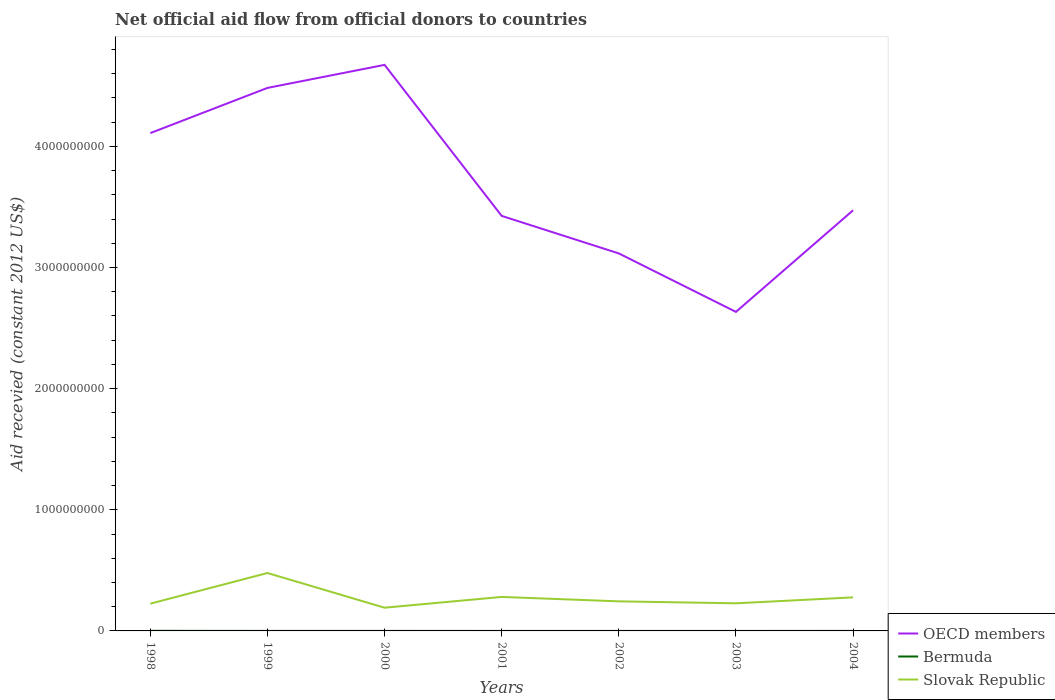How many different coloured lines are there?
Ensure brevity in your answer.  3. Is the number of lines equal to the number of legend labels?
Your response must be concise. Yes. Across all years, what is the maximum total aid received in Slovak Republic?
Keep it short and to the point. 1.92e+08. What is the total total aid received in OECD members in the graph?
Keep it short and to the point. -8.39e+08. What is the difference between the highest and the second highest total aid received in OECD members?
Your answer should be compact. 2.04e+09. How many years are there in the graph?
Your answer should be very brief. 7. Are the values on the major ticks of Y-axis written in scientific E-notation?
Your response must be concise. No. Does the graph contain any zero values?
Ensure brevity in your answer.  No. Where does the legend appear in the graph?
Ensure brevity in your answer.  Bottom right. How many legend labels are there?
Offer a very short reply. 3. What is the title of the graph?
Offer a terse response. Net official aid flow from official donors to countries. Does "North America" appear as one of the legend labels in the graph?
Make the answer very short. No. What is the label or title of the X-axis?
Ensure brevity in your answer.  Years. What is the label or title of the Y-axis?
Give a very brief answer. Aid recevied (constant 2012 US$). What is the Aid recevied (constant 2012 US$) of OECD members in 1998?
Offer a very short reply. 4.11e+09. What is the Aid recevied (constant 2012 US$) of Bermuda in 1998?
Give a very brief answer. 7.40e+05. What is the Aid recevied (constant 2012 US$) in Slovak Republic in 1998?
Give a very brief answer. 2.25e+08. What is the Aid recevied (constant 2012 US$) of OECD members in 1999?
Make the answer very short. 4.48e+09. What is the Aid recevied (constant 2012 US$) in Bermuda in 1999?
Your answer should be very brief. 1.30e+05. What is the Aid recevied (constant 2012 US$) in Slovak Republic in 1999?
Your answer should be compact. 4.78e+08. What is the Aid recevied (constant 2012 US$) of OECD members in 2000?
Provide a short and direct response. 4.67e+09. What is the Aid recevied (constant 2012 US$) of Bermuda in 2000?
Keep it short and to the point. 1.10e+05. What is the Aid recevied (constant 2012 US$) in Slovak Republic in 2000?
Your response must be concise. 1.92e+08. What is the Aid recevied (constant 2012 US$) in OECD members in 2001?
Offer a very short reply. 3.43e+09. What is the Aid recevied (constant 2012 US$) in Bermuda in 2001?
Ensure brevity in your answer.  4.00e+04. What is the Aid recevied (constant 2012 US$) in Slovak Republic in 2001?
Offer a terse response. 2.81e+08. What is the Aid recevied (constant 2012 US$) of OECD members in 2002?
Ensure brevity in your answer.  3.12e+09. What is the Aid recevied (constant 2012 US$) in Slovak Republic in 2002?
Your answer should be very brief. 2.44e+08. What is the Aid recevied (constant 2012 US$) in OECD members in 2003?
Offer a very short reply. 2.63e+09. What is the Aid recevied (constant 2012 US$) of Bermuda in 2003?
Provide a succinct answer. 4.00e+04. What is the Aid recevied (constant 2012 US$) in Slovak Republic in 2003?
Keep it short and to the point. 2.28e+08. What is the Aid recevied (constant 2012 US$) in OECD members in 2004?
Ensure brevity in your answer.  3.47e+09. What is the Aid recevied (constant 2012 US$) of Slovak Republic in 2004?
Ensure brevity in your answer.  2.77e+08. Across all years, what is the maximum Aid recevied (constant 2012 US$) of OECD members?
Your answer should be compact. 4.67e+09. Across all years, what is the maximum Aid recevied (constant 2012 US$) of Bermuda?
Offer a terse response. 7.40e+05. Across all years, what is the maximum Aid recevied (constant 2012 US$) in Slovak Republic?
Ensure brevity in your answer.  4.78e+08. Across all years, what is the minimum Aid recevied (constant 2012 US$) in OECD members?
Keep it short and to the point. 2.63e+09. Across all years, what is the minimum Aid recevied (constant 2012 US$) in Slovak Republic?
Keep it short and to the point. 1.92e+08. What is the total Aid recevied (constant 2012 US$) in OECD members in the graph?
Keep it short and to the point. 2.59e+1. What is the total Aid recevied (constant 2012 US$) in Bermuda in the graph?
Ensure brevity in your answer.  1.20e+06. What is the total Aid recevied (constant 2012 US$) of Slovak Republic in the graph?
Offer a terse response. 1.92e+09. What is the difference between the Aid recevied (constant 2012 US$) of OECD members in 1998 and that in 1999?
Make the answer very short. -3.73e+08. What is the difference between the Aid recevied (constant 2012 US$) of Bermuda in 1998 and that in 1999?
Provide a succinct answer. 6.10e+05. What is the difference between the Aid recevied (constant 2012 US$) of Slovak Republic in 1998 and that in 1999?
Provide a short and direct response. -2.53e+08. What is the difference between the Aid recevied (constant 2012 US$) in OECD members in 1998 and that in 2000?
Provide a succinct answer. -5.63e+08. What is the difference between the Aid recevied (constant 2012 US$) of Bermuda in 1998 and that in 2000?
Keep it short and to the point. 6.30e+05. What is the difference between the Aid recevied (constant 2012 US$) in Slovak Republic in 1998 and that in 2000?
Make the answer very short. 3.33e+07. What is the difference between the Aid recevied (constant 2012 US$) of OECD members in 1998 and that in 2001?
Your answer should be very brief. 6.84e+08. What is the difference between the Aid recevied (constant 2012 US$) in Bermuda in 1998 and that in 2001?
Provide a short and direct response. 7.00e+05. What is the difference between the Aid recevied (constant 2012 US$) of Slovak Republic in 1998 and that in 2001?
Provide a short and direct response. -5.56e+07. What is the difference between the Aid recevied (constant 2012 US$) of OECD members in 1998 and that in 2002?
Offer a terse response. 9.93e+08. What is the difference between the Aid recevied (constant 2012 US$) of Bermuda in 1998 and that in 2002?
Your response must be concise. 7.10e+05. What is the difference between the Aid recevied (constant 2012 US$) in Slovak Republic in 1998 and that in 2002?
Provide a short and direct response. -1.91e+07. What is the difference between the Aid recevied (constant 2012 US$) of OECD members in 1998 and that in 2003?
Provide a short and direct response. 1.48e+09. What is the difference between the Aid recevied (constant 2012 US$) in Slovak Republic in 1998 and that in 2003?
Offer a terse response. -2.98e+06. What is the difference between the Aid recevied (constant 2012 US$) of OECD members in 1998 and that in 2004?
Your answer should be very brief. 6.38e+08. What is the difference between the Aid recevied (constant 2012 US$) of Bermuda in 1998 and that in 2004?
Your answer should be compact. 6.30e+05. What is the difference between the Aid recevied (constant 2012 US$) of Slovak Republic in 1998 and that in 2004?
Your answer should be very brief. -5.20e+07. What is the difference between the Aid recevied (constant 2012 US$) in OECD members in 1999 and that in 2000?
Provide a succinct answer. -1.90e+08. What is the difference between the Aid recevied (constant 2012 US$) in Bermuda in 1999 and that in 2000?
Provide a short and direct response. 2.00e+04. What is the difference between the Aid recevied (constant 2012 US$) of Slovak Republic in 1999 and that in 2000?
Your answer should be compact. 2.86e+08. What is the difference between the Aid recevied (constant 2012 US$) in OECD members in 1999 and that in 2001?
Give a very brief answer. 1.06e+09. What is the difference between the Aid recevied (constant 2012 US$) of Bermuda in 1999 and that in 2001?
Make the answer very short. 9.00e+04. What is the difference between the Aid recevied (constant 2012 US$) of Slovak Republic in 1999 and that in 2001?
Offer a very short reply. 1.98e+08. What is the difference between the Aid recevied (constant 2012 US$) in OECD members in 1999 and that in 2002?
Provide a short and direct response. 1.37e+09. What is the difference between the Aid recevied (constant 2012 US$) in Bermuda in 1999 and that in 2002?
Ensure brevity in your answer.  1.00e+05. What is the difference between the Aid recevied (constant 2012 US$) of Slovak Republic in 1999 and that in 2002?
Your response must be concise. 2.34e+08. What is the difference between the Aid recevied (constant 2012 US$) of OECD members in 1999 and that in 2003?
Your answer should be very brief. 1.85e+09. What is the difference between the Aid recevied (constant 2012 US$) in Bermuda in 1999 and that in 2003?
Your answer should be very brief. 9.00e+04. What is the difference between the Aid recevied (constant 2012 US$) in Slovak Republic in 1999 and that in 2003?
Your answer should be compact. 2.50e+08. What is the difference between the Aid recevied (constant 2012 US$) of OECD members in 1999 and that in 2004?
Give a very brief answer. 1.01e+09. What is the difference between the Aid recevied (constant 2012 US$) of Slovak Republic in 1999 and that in 2004?
Your answer should be very brief. 2.01e+08. What is the difference between the Aid recevied (constant 2012 US$) in OECD members in 2000 and that in 2001?
Your answer should be compact. 1.25e+09. What is the difference between the Aid recevied (constant 2012 US$) of Bermuda in 2000 and that in 2001?
Provide a succinct answer. 7.00e+04. What is the difference between the Aid recevied (constant 2012 US$) of Slovak Republic in 2000 and that in 2001?
Keep it short and to the point. -8.90e+07. What is the difference between the Aid recevied (constant 2012 US$) in OECD members in 2000 and that in 2002?
Your answer should be very brief. 1.56e+09. What is the difference between the Aid recevied (constant 2012 US$) of Slovak Republic in 2000 and that in 2002?
Offer a terse response. -5.24e+07. What is the difference between the Aid recevied (constant 2012 US$) of OECD members in 2000 and that in 2003?
Make the answer very short. 2.04e+09. What is the difference between the Aid recevied (constant 2012 US$) of Bermuda in 2000 and that in 2003?
Keep it short and to the point. 7.00e+04. What is the difference between the Aid recevied (constant 2012 US$) of Slovak Republic in 2000 and that in 2003?
Offer a very short reply. -3.63e+07. What is the difference between the Aid recevied (constant 2012 US$) of OECD members in 2000 and that in 2004?
Provide a short and direct response. 1.20e+09. What is the difference between the Aid recevied (constant 2012 US$) of Bermuda in 2000 and that in 2004?
Your response must be concise. 0. What is the difference between the Aid recevied (constant 2012 US$) of Slovak Republic in 2000 and that in 2004?
Your answer should be compact. -8.53e+07. What is the difference between the Aid recevied (constant 2012 US$) in OECD members in 2001 and that in 2002?
Offer a terse response. 3.10e+08. What is the difference between the Aid recevied (constant 2012 US$) of Slovak Republic in 2001 and that in 2002?
Make the answer very short. 3.66e+07. What is the difference between the Aid recevied (constant 2012 US$) of OECD members in 2001 and that in 2003?
Provide a succinct answer. 7.93e+08. What is the difference between the Aid recevied (constant 2012 US$) in Bermuda in 2001 and that in 2003?
Provide a succinct answer. 0. What is the difference between the Aid recevied (constant 2012 US$) in Slovak Republic in 2001 and that in 2003?
Ensure brevity in your answer.  5.27e+07. What is the difference between the Aid recevied (constant 2012 US$) of OECD members in 2001 and that in 2004?
Your response must be concise. -4.60e+07. What is the difference between the Aid recevied (constant 2012 US$) in Slovak Republic in 2001 and that in 2004?
Provide a short and direct response. 3.66e+06. What is the difference between the Aid recevied (constant 2012 US$) of OECD members in 2002 and that in 2003?
Make the answer very short. 4.83e+08. What is the difference between the Aid recevied (constant 2012 US$) of Bermuda in 2002 and that in 2003?
Your answer should be compact. -10000. What is the difference between the Aid recevied (constant 2012 US$) of Slovak Republic in 2002 and that in 2003?
Ensure brevity in your answer.  1.61e+07. What is the difference between the Aid recevied (constant 2012 US$) of OECD members in 2002 and that in 2004?
Ensure brevity in your answer.  -3.56e+08. What is the difference between the Aid recevied (constant 2012 US$) in Bermuda in 2002 and that in 2004?
Keep it short and to the point. -8.00e+04. What is the difference between the Aid recevied (constant 2012 US$) of Slovak Republic in 2002 and that in 2004?
Offer a terse response. -3.29e+07. What is the difference between the Aid recevied (constant 2012 US$) in OECD members in 2003 and that in 2004?
Offer a terse response. -8.39e+08. What is the difference between the Aid recevied (constant 2012 US$) in Slovak Republic in 2003 and that in 2004?
Your response must be concise. -4.90e+07. What is the difference between the Aid recevied (constant 2012 US$) of OECD members in 1998 and the Aid recevied (constant 2012 US$) of Bermuda in 1999?
Make the answer very short. 4.11e+09. What is the difference between the Aid recevied (constant 2012 US$) of OECD members in 1998 and the Aid recevied (constant 2012 US$) of Slovak Republic in 1999?
Provide a succinct answer. 3.63e+09. What is the difference between the Aid recevied (constant 2012 US$) of Bermuda in 1998 and the Aid recevied (constant 2012 US$) of Slovak Republic in 1999?
Provide a succinct answer. -4.77e+08. What is the difference between the Aid recevied (constant 2012 US$) of OECD members in 1998 and the Aid recevied (constant 2012 US$) of Bermuda in 2000?
Your response must be concise. 4.11e+09. What is the difference between the Aid recevied (constant 2012 US$) in OECD members in 1998 and the Aid recevied (constant 2012 US$) in Slovak Republic in 2000?
Your answer should be very brief. 3.92e+09. What is the difference between the Aid recevied (constant 2012 US$) in Bermuda in 1998 and the Aid recevied (constant 2012 US$) in Slovak Republic in 2000?
Give a very brief answer. -1.91e+08. What is the difference between the Aid recevied (constant 2012 US$) of OECD members in 1998 and the Aid recevied (constant 2012 US$) of Bermuda in 2001?
Make the answer very short. 4.11e+09. What is the difference between the Aid recevied (constant 2012 US$) in OECD members in 1998 and the Aid recevied (constant 2012 US$) in Slovak Republic in 2001?
Provide a short and direct response. 3.83e+09. What is the difference between the Aid recevied (constant 2012 US$) in Bermuda in 1998 and the Aid recevied (constant 2012 US$) in Slovak Republic in 2001?
Your answer should be very brief. -2.80e+08. What is the difference between the Aid recevied (constant 2012 US$) in OECD members in 1998 and the Aid recevied (constant 2012 US$) in Bermuda in 2002?
Your answer should be compact. 4.11e+09. What is the difference between the Aid recevied (constant 2012 US$) in OECD members in 1998 and the Aid recevied (constant 2012 US$) in Slovak Republic in 2002?
Your response must be concise. 3.87e+09. What is the difference between the Aid recevied (constant 2012 US$) in Bermuda in 1998 and the Aid recevied (constant 2012 US$) in Slovak Republic in 2002?
Your answer should be compact. -2.43e+08. What is the difference between the Aid recevied (constant 2012 US$) in OECD members in 1998 and the Aid recevied (constant 2012 US$) in Bermuda in 2003?
Your response must be concise. 4.11e+09. What is the difference between the Aid recevied (constant 2012 US$) in OECD members in 1998 and the Aid recevied (constant 2012 US$) in Slovak Republic in 2003?
Your response must be concise. 3.88e+09. What is the difference between the Aid recevied (constant 2012 US$) in Bermuda in 1998 and the Aid recevied (constant 2012 US$) in Slovak Republic in 2003?
Offer a very short reply. -2.27e+08. What is the difference between the Aid recevied (constant 2012 US$) in OECD members in 1998 and the Aid recevied (constant 2012 US$) in Bermuda in 2004?
Your answer should be compact. 4.11e+09. What is the difference between the Aid recevied (constant 2012 US$) in OECD members in 1998 and the Aid recevied (constant 2012 US$) in Slovak Republic in 2004?
Ensure brevity in your answer.  3.83e+09. What is the difference between the Aid recevied (constant 2012 US$) of Bermuda in 1998 and the Aid recevied (constant 2012 US$) of Slovak Republic in 2004?
Your answer should be compact. -2.76e+08. What is the difference between the Aid recevied (constant 2012 US$) of OECD members in 1999 and the Aid recevied (constant 2012 US$) of Bermuda in 2000?
Your answer should be very brief. 4.48e+09. What is the difference between the Aid recevied (constant 2012 US$) of OECD members in 1999 and the Aid recevied (constant 2012 US$) of Slovak Republic in 2000?
Provide a succinct answer. 4.29e+09. What is the difference between the Aid recevied (constant 2012 US$) of Bermuda in 1999 and the Aid recevied (constant 2012 US$) of Slovak Republic in 2000?
Keep it short and to the point. -1.92e+08. What is the difference between the Aid recevied (constant 2012 US$) of OECD members in 1999 and the Aid recevied (constant 2012 US$) of Bermuda in 2001?
Offer a terse response. 4.48e+09. What is the difference between the Aid recevied (constant 2012 US$) in OECD members in 1999 and the Aid recevied (constant 2012 US$) in Slovak Republic in 2001?
Your answer should be very brief. 4.20e+09. What is the difference between the Aid recevied (constant 2012 US$) of Bermuda in 1999 and the Aid recevied (constant 2012 US$) of Slovak Republic in 2001?
Make the answer very short. -2.81e+08. What is the difference between the Aid recevied (constant 2012 US$) in OECD members in 1999 and the Aid recevied (constant 2012 US$) in Bermuda in 2002?
Your answer should be very brief. 4.48e+09. What is the difference between the Aid recevied (constant 2012 US$) of OECD members in 1999 and the Aid recevied (constant 2012 US$) of Slovak Republic in 2002?
Offer a very short reply. 4.24e+09. What is the difference between the Aid recevied (constant 2012 US$) in Bermuda in 1999 and the Aid recevied (constant 2012 US$) in Slovak Republic in 2002?
Provide a short and direct response. -2.44e+08. What is the difference between the Aid recevied (constant 2012 US$) of OECD members in 1999 and the Aid recevied (constant 2012 US$) of Bermuda in 2003?
Give a very brief answer. 4.48e+09. What is the difference between the Aid recevied (constant 2012 US$) in OECD members in 1999 and the Aid recevied (constant 2012 US$) in Slovak Republic in 2003?
Make the answer very short. 4.25e+09. What is the difference between the Aid recevied (constant 2012 US$) of Bermuda in 1999 and the Aid recevied (constant 2012 US$) of Slovak Republic in 2003?
Provide a succinct answer. -2.28e+08. What is the difference between the Aid recevied (constant 2012 US$) in OECD members in 1999 and the Aid recevied (constant 2012 US$) in Bermuda in 2004?
Give a very brief answer. 4.48e+09. What is the difference between the Aid recevied (constant 2012 US$) of OECD members in 1999 and the Aid recevied (constant 2012 US$) of Slovak Republic in 2004?
Offer a terse response. 4.21e+09. What is the difference between the Aid recevied (constant 2012 US$) in Bermuda in 1999 and the Aid recevied (constant 2012 US$) in Slovak Republic in 2004?
Provide a short and direct response. -2.77e+08. What is the difference between the Aid recevied (constant 2012 US$) in OECD members in 2000 and the Aid recevied (constant 2012 US$) in Bermuda in 2001?
Your answer should be very brief. 4.67e+09. What is the difference between the Aid recevied (constant 2012 US$) in OECD members in 2000 and the Aid recevied (constant 2012 US$) in Slovak Republic in 2001?
Offer a terse response. 4.39e+09. What is the difference between the Aid recevied (constant 2012 US$) of Bermuda in 2000 and the Aid recevied (constant 2012 US$) of Slovak Republic in 2001?
Ensure brevity in your answer.  -2.81e+08. What is the difference between the Aid recevied (constant 2012 US$) of OECD members in 2000 and the Aid recevied (constant 2012 US$) of Bermuda in 2002?
Your response must be concise. 4.67e+09. What is the difference between the Aid recevied (constant 2012 US$) of OECD members in 2000 and the Aid recevied (constant 2012 US$) of Slovak Republic in 2002?
Offer a terse response. 4.43e+09. What is the difference between the Aid recevied (constant 2012 US$) of Bermuda in 2000 and the Aid recevied (constant 2012 US$) of Slovak Republic in 2002?
Offer a terse response. -2.44e+08. What is the difference between the Aid recevied (constant 2012 US$) of OECD members in 2000 and the Aid recevied (constant 2012 US$) of Bermuda in 2003?
Offer a terse response. 4.67e+09. What is the difference between the Aid recevied (constant 2012 US$) in OECD members in 2000 and the Aid recevied (constant 2012 US$) in Slovak Republic in 2003?
Make the answer very short. 4.44e+09. What is the difference between the Aid recevied (constant 2012 US$) of Bermuda in 2000 and the Aid recevied (constant 2012 US$) of Slovak Republic in 2003?
Your answer should be very brief. -2.28e+08. What is the difference between the Aid recevied (constant 2012 US$) of OECD members in 2000 and the Aid recevied (constant 2012 US$) of Bermuda in 2004?
Provide a succinct answer. 4.67e+09. What is the difference between the Aid recevied (constant 2012 US$) in OECD members in 2000 and the Aid recevied (constant 2012 US$) in Slovak Republic in 2004?
Provide a short and direct response. 4.40e+09. What is the difference between the Aid recevied (constant 2012 US$) of Bermuda in 2000 and the Aid recevied (constant 2012 US$) of Slovak Republic in 2004?
Offer a terse response. -2.77e+08. What is the difference between the Aid recevied (constant 2012 US$) in OECD members in 2001 and the Aid recevied (constant 2012 US$) in Bermuda in 2002?
Your answer should be compact. 3.43e+09. What is the difference between the Aid recevied (constant 2012 US$) of OECD members in 2001 and the Aid recevied (constant 2012 US$) of Slovak Republic in 2002?
Provide a succinct answer. 3.18e+09. What is the difference between the Aid recevied (constant 2012 US$) of Bermuda in 2001 and the Aid recevied (constant 2012 US$) of Slovak Republic in 2002?
Offer a very short reply. -2.44e+08. What is the difference between the Aid recevied (constant 2012 US$) of OECD members in 2001 and the Aid recevied (constant 2012 US$) of Bermuda in 2003?
Provide a succinct answer. 3.43e+09. What is the difference between the Aid recevied (constant 2012 US$) in OECD members in 2001 and the Aid recevied (constant 2012 US$) in Slovak Republic in 2003?
Your response must be concise. 3.20e+09. What is the difference between the Aid recevied (constant 2012 US$) of Bermuda in 2001 and the Aid recevied (constant 2012 US$) of Slovak Republic in 2003?
Make the answer very short. -2.28e+08. What is the difference between the Aid recevied (constant 2012 US$) in OECD members in 2001 and the Aid recevied (constant 2012 US$) in Bermuda in 2004?
Your answer should be very brief. 3.43e+09. What is the difference between the Aid recevied (constant 2012 US$) of OECD members in 2001 and the Aid recevied (constant 2012 US$) of Slovak Republic in 2004?
Provide a succinct answer. 3.15e+09. What is the difference between the Aid recevied (constant 2012 US$) in Bermuda in 2001 and the Aid recevied (constant 2012 US$) in Slovak Republic in 2004?
Keep it short and to the point. -2.77e+08. What is the difference between the Aid recevied (constant 2012 US$) in OECD members in 2002 and the Aid recevied (constant 2012 US$) in Bermuda in 2003?
Your answer should be compact. 3.12e+09. What is the difference between the Aid recevied (constant 2012 US$) in OECD members in 2002 and the Aid recevied (constant 2012 US$) in Slovak Republic in 2003?
Offer a very short reply. 2.89e+09. What is the difference between the Aid recevied (constant 2012 US$) in Bermuda in 2002 and the Aid recevied (constant 2012 US$) in Slovak Republic in 2003?
Offer a very short reply. -2.28e+08. What is the difference between the Aid recevied (constant 2012 US$) in OECD members in 2002 and the Aid recevied (constant 2012 US$) in Bermuda in 2004?
Offer a terse response. 3.12e+09. What is the difference between the Aid recevied (constant 2012 US$) in OECD members in 2002 and the Aid recevied (constant 2012 US$) in Slovak Republic in 2004?
Keep it short and to the point. 2.84e+09. What is the difference between the Aid recevied (constant 2012 US$) in Bermuda in 2002 and the Aid recevied (constant 2012 US$) in Slovak Republic in 2004?
Your answer should be compact. -2.77e+08. What is the difference between the Aid recevied (constant 2012 US$) of OECD members in 2003 and the Aid recevied (constant 2012 US$) of Bermuda in 2004?
Provide a short and direct response. 2.63e+09. What is the difference between the Aid recevied (constant 2012 US$) in OECD members in 2003 and the Aid recevied (constant 2012 US$) in Slovak Republic in 2004?
Your answer should be very brief. 2.36e+09. What is the difference between the Aid recevied (constant 2012 US$) in Bermuda in 2003 and the Aid recevied (constant 2012 US$) in Slovak Republic in 2004?
Make the answer very short. -2.77e+08. What is the average Aid recevied (constant 2012 US$) of OECD members per year?
Ensure brevity in your answer.  3.70e+09. What is the average Aid recevied (constant 2012 US$) in Bermuda per year?
Give a very brief answer. 1.71e+05. What is the average Aid recevied (constant 2012 US$) of Slovak Republic per year?
Offer a very short reply. 2.75e+08. In the year 1998, what is the difference between the Aid recevied (constant 2012 US$) of OECD members and Aid recevied (constant 2012 US$) of Bermuda?
Keep it short and to the point. 4.11e+09. In the year 1998, what is the difference between the Aid recevied (constant 2012 US$) of OECD members and Aid recevied (constant 2012 US$) of Slovak Republic?
Your answer should be very brief. 3.88e+09. In the year 1998, what is the difference between the Aid recevied (constant 2012 US$) in Bermuda and Aid recevied (constant 2012 US$) in Slovak Republic?
Your answer should be compact. -2.24e+08. In the year 1999, what is the difference between the Aid recevied (constant 2012 US$) of OECD members and Aid recevied (constant 2012 US$) of Bermuda?
Keep it short and to the point. 4.48e+09. In the year 1999, what is the difference between the Aid recevied (constant 2012 US$) in OECD members and Aid recevied (constant 2012 US$) in Slovak Republic?
Offer a very short reply. 4.00e+09. In the year 1999, what is the difference between the Aid recevied (constant 2012 US$) of Bermuda and Aid recevied (constant 2012 US$) of Slovak Republic?
Provide a short and direct response. -4.78e+08. In the year 2000, what is the difference between the Aid recevied (constant 2012 US$) in OECD members and Aid recevied (constant 2012 US$) in Bermuda?
Give a very brief answer. 4.67e+09. In the year 2000, what is the difference between the Aid recevied (constant 2012 US$) in OECD members and Aid recevied (constant 2012 US$) in Slovak Republic?
Your answer should be very brief. 4.48e+09. In the year 2000, what is the difference between the Aid recevied (constant 2012 US$) in Bermuda and Aid recevied (constant 2012 US$) in Slovak Republic?
Offer a very short reply. -1.92e+08. In the year 2001, what is the difference between the Aid recevied (constant 2012 US$) in OECD members and Aid recevied (constant 2012 US$) in Bermuda?
Your response must be concise. 3.43e+09. In the year 2001, what is the difference between the Aid recevied (constant 2012 US$) in OECD members and Aid recevied (constant 2012 US$) in Slovak Republic?
Make the answer very short. 3.15e+09. In the year 2001, what is the difference between the Aid recevied (constant 2012 US$) in Bermuda and Aid recevied (constant 2012 US$) in Slovak Republic?
Provide a short and direct response. -2.81e+08. In the year 2002, what is the difference between the Aid recevied (constant 2012 US$) of OECD members and Aid recevied (constant 2012 US$) of Bermuda?
Your answer should be very brief. 3.12e+09. In the year 2002, what is the difference between the Aid recevied (constant 2012 US$) of OECD members and Aid recevied (constant 2012 US$) of Slovak Republic?
Provide a succinct answer. 2.87e+09. In the year 2002, what is the difference between the Aid recevied (constant 2012 US$) of Bermuda and Aid recevied (constant 2012 US$) of Slovak Republic?
Your response must be concise. -2.44e+08. In the year 2003, what is the difference between the Aid recevied (constant 2012 US$) of OECD members and Aid recevied (constant 2012 US$) of Bermuda?
Provide a short and direct response. 2.63e+09. In the year 2003, what is the difference between the Aid recevied (constant 2012 US$) in OECD members and Aid recevied (constant 2012 US$) in Slovak Republic?
Offer a terse response. 2.41e+09. In the year 2003, what is the difference between the Aid recevied (constant 2012 US$) of Bermuda and Aid recevied (constant 2012 US$) of Slovak Republic?
Provide a short and direct response. -2.28e+08. In the year 2004, what is the difference between the Aid recevied (constant 2012 US$) in OECD members and Aid recevied (constant 2012 US$) in Bermuda?
Your answer should be very brief. 3.47e+09. In the year 2004, what is the difference between the Aid recevied (constant 2012 US$) of OECD members and Aid recevied (constant 2012 US$) of Slovak Republic?
Give a very brief answer. 3.20e+09. In the year 2004, what is the difference between the Aid recevied (constant 2012 US$) of Bermuda and Aid recevied (constant 2012 US$) of Slovak Republic?
Your answer should be very brief. -2.77e+08. What is the ratio of the Aid recevied (constant 2012 US$) of OECD members in 1998 to that in 1999?
Your answer should be compact. 0.92. What is the ratio of the Aid recevied (constant 2012 US$) in Bermuda in 1998 to that in 1999?
Offer a very short reply. 5.69. What is the ratio of the Aid recevied (constant 2012 US$) in Slovak Republic in 1998 to that in 1999?
Provide a succinct answer. 0.47. What is the ratio of the Aid recevied (constant 2012 US$) of OECD members in 1998 to that in 2000?
Offer a very short reply. 0.88. What is the ratio of the Aid recevied (constant 2012 US$) in Bermuda in 1998 to that in 2000?
Your response must be concise. 6.73. What is the ratio of the Aid recevied (constant 2012 US$) in Slovak Republic in 1998 to that in 2000?
Your response must be concise. 1.17. What is the ratio of the Aid recevied (constant 2012 US$) in OECD members in 1998 to that in 2001?
Your answer should be compact. 1.2. What is the ratio of the Aid recevied (constant 2012 US$) in Bermuda in 1998 to that in 2001?
Give a very brief answer. 18.5. What is the ratio of the Aid recevied (constant 2012 US$) of Slovak Republic in 1998 to that in 2001?
Your answer should be compact. 0.8. What is the ratio of the Aid recevied (constant 2012 US$) in OECD members in 1998 to that in 2002?
Offer a very short reply. 1.32. What is the ratio of the Aid recevied (constant 2012 US$) of Bermuda in 1998 to that in 2002?
Your answer should be compact. 24.67. What is the ratio of the Aid recevied (constant 2012 US$) in Slovak Republic in 1998 to that in 2002?
Your response must be concise. 0.92. What is the ratio of the Aid recevied (constant 2012 US$) of OECD members in 1998 to that in 2003?
Make the answer very short. 1.56. What is the ratio of the Aid recevied (constant 2012 US$) in Slovak Republic in 1998 to that in 2003?
Make the answer very short. 0.99. What is the ratio of the Aid recevied (constant 2012 US$) of OECD members in 1998 to that in 2004?
Keep it short and to the point. 1.18. What is the ratio of the Aid recevied (constant 2012 US$) of Bermuda in 1998 to that in 2004?
Offer a very short reply. 6.73. What is the ratio of the Aid recevied (constant 2012 US$) of Slovak Republic in 1998 to that in 2004?
Your response must be concise. 0.81. What is the ratio of the Aid recevied (constant 2012 US$) in OECD members in 1999 to that in 2000?
Your response must be concise. 0.96. What is the ratio of the Aid recevied (constant 2012 US$) in Bermuda in 1999 to that in 2000?
Provide a short and direct response. 1.18. What is the ratio of the Aid recevied (constant 2012 US$) of Slovak Republic in 1999 to that in 2000?
Your answer should be compact. 2.49. What is the ratio of the Aid recevied (constant 2012 US$) of OECD members in 1999 to that in 2001?
Offer a very short reply. 1.31. What is the ratio of the Aid recevied (constant 2012 US$) in Slovak Republic in 1999 to that in 2001?
Keep it short and to the point. 1.7. What is the ratio of the Aid recevied (constant 2012 US$) in OECD members in 1999 to that in 2002?
Your response must be concise. 1.44. What is the ratio of the Aid recevied (constant 2012 US$) in Bermuda in 1999 to that in 2002?
Your answer should be compact. 4.33. What is the ratio of the Aid recevied (constant 2012 US$) in Slovak Republic in 1999 to that in 2002?
Offer a terse response. 1.96. What is the ratio of the Aid recevied (constant 2012 US$) in OECD members in 1999 to that in 2003?
Offer a very short reply. 1.7. What is the ratio of the Aid recevied (constant 2012 US$) of Slovak Republic in 1999 to that in 2003?
Keep it short and to the point. 2.1. What is the ratio of the Aid recevied (constant 2012 US$) of OECD members in 1999 to that in 2004?
Offer a terse response. 1.29. What is the ratio of the Aid recevied (constant 2012 US$) in Bermuda in 1999 to that in 2004?
Make the answer very short. 1.18. What is the ratio of the Aid recevied (constant 2012 US$) of Slovak Republic in 1999 to that in 2004?
Keep it short and to the point. 1.73. What is the ratio of the Aid recevied (constant 2012 US$) of OECD members in 2000 to that in 2001?
Ensure brevity in your answer.  1.36. What is the ratio of the Aid recevied (constant 2012 US$) of Bermuda in 2000 to that in 2001?
Your answer should be compact. 2.75. What is the ratio of the Aid recevied (constant 2012 US$) in Slovak Republic in 2000 to that in 2001?
Offer a terse response. 0.68. What is the ratio of the Aid recevied (constant 2012 US$) in OECD members in 2000 to that in 2002?
Offer a very short reply. 1.5. What is the ratio of the Aid recevied (constant 2012 US$) of Bermuda in 2000 to that in 2002?
Give a very brief answer. 3.67. What is the ratio of the Aid recevied (constant 2012 US$) of Slovak Republic in 2000 to that in 2002?
Offer a terse response. 0.79. What is the ratio of the Aid recevied (constant 2012 US$) of OECD members in 2000 to that in 2003?
Make the answer very short. 1.77. What is the ratio of the Aid recevied (constant 2012 US$) of Bermuda in 2000 to that in 2003?
Make the answer very short. 2.75. What is the ratio of the Aid recevied (constant 2012 US$) of Slovak Republic in 2000 to that in 2003?
Your answer should be compact. 0.84. What is the ratio of the Aid recevied (constant 2012 US$) in OECD members in 2000 to that in 2004?
Offer a very short reply. 1.35. What is the ratio of the Aid recevied (constant 2012 US$) of Slovak Republic in 2000 to that in 2004?
Your answer should be compact. 0.69. What is the ratio of the Aid recevied (constant 2012 US$) of OECD members in 2001 to that in 2002?
Your answer should be very brief. 1.1. What is the ratio of the Aid recevied (constant 2012 US$) of Slovak Republic in 2001 to that in 2002?
Your answer should be compact. 1.15. What is the ratio of the Aid recevied (constant 2012 US$) in OECD members in 2001 to that in 2003?
Offer a very short reply. 1.3. What is the ratio of the Aid recevied (constant 2012 US$) of Bermuda in 2001 to that in 2003?
Provide a short and direct response. 1. What is the ratio of the Aid recevied (constant 2012 US$) in Slovak Republic in 2001 to that in 2003?
Provide a short and direct response. 1.23. What is the ratio of the Aid recevied (constant 2012 US$) in OECD members in 2001 to that in 2004?
Provide a succinct answer. 0.99. What is the ratio of the Aid recevied (constant 2012 US$) of Bermuda in 2001 to that in 2004?
Offer a very short reply. 0.36. What is the ratio of the Aid recevied (constant 2012 US$) in Slovak Republic in 2001 to that in 2004?
Your answer should be very brief. 1.01. What is the ratio of the Aid recevied (constant 2012 US$) in OECD members in 2002 to that in 2003?
Offer a terse response. 1.18. What is the ratio of the Aid recevied (constant 2012 US$) of Bermuda in 2002 to that in 2003?
Your answer should be very brief. 0.75. What is the ratio of the Aid recevied (constant 2012 US$) in Slovak Republic in 2002 to that in 2003?
Make the answer very short. 1.07. What is the ratio of the Aid recevied (constant 2012 US$) of OECD members in 2002 to that in 2004?
Offer a terse response. 0.9. What is the ratio of the Aid recevied (constant 2012 US$) of Bermuda in 2002 to that in 2004?
Your response must be concise. 0.27. What is the ratio of the Aid recevied (constant 2012 US$) in Slovak Republic in 2002 to that in 2004?
Your response must be concise. 0.88. What is the ratio of the Aid recevied (constant 2012 US$) of OECD members in 2003 to that in 2004?
Your answer should be very brief. 0.76. What is the ratio of the Aid recevied (constant 2012 US$) in Bermuda in 2003 to that in 2004?
Offer a terse response. 0.36. What is the ratio of the Aid recevied (constant 2012 US$) in Slovak Republic in 2003 to that in 2004?
Your answer should be compact. 0.82. What is the difference between the highest and the second highest Aid recevied (constant 2012 US$) in OECD members?
Ensure brevity in your answer.  1.90e+08. What is the difference between the highest and the second highest Aid recevied (constant 2012 US$) of Slovak Republic?
Offer a very short reply. 1.98e+08. What is the difference between the highest and the lowest Aid recevied (constant 2012 US$) of OECD members?
Ensure brevity in your answer.  2.04e+09. What is the difference between the highest and the lowest Aid recevied (constant 2012 US$) of Bermuda?
Make the answer very short. 7.10e+05. What is the difference between the highest and the lowest Aid recevied (constant 2012 US$) of Slovak Republic?
Offer a terse response. 2.86e+08. 